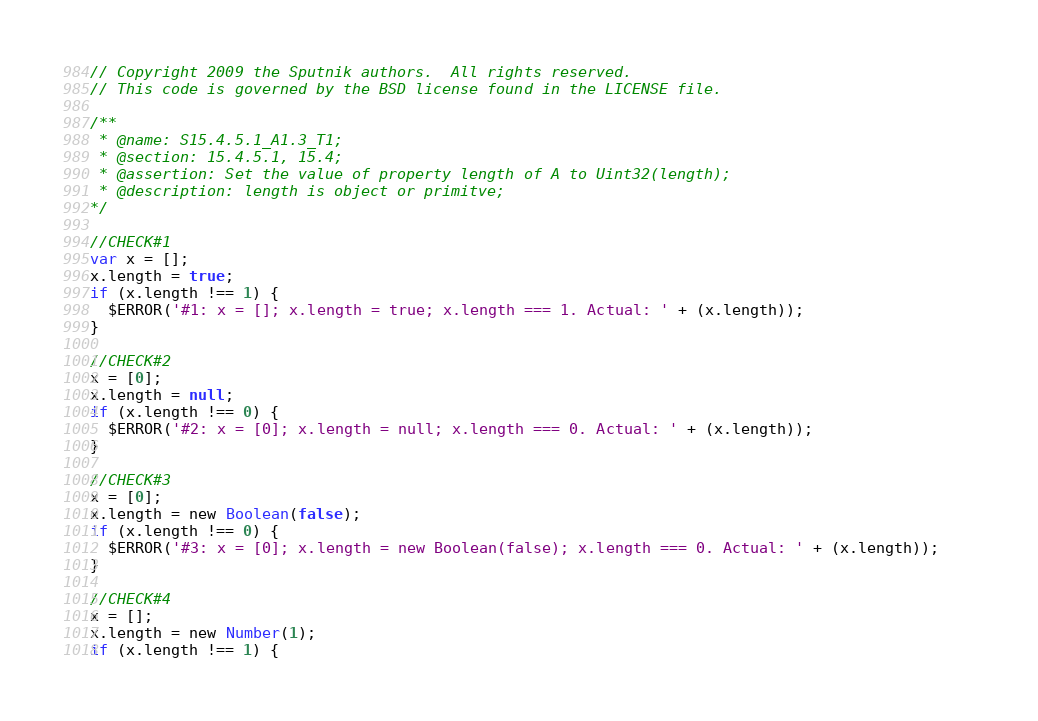<code> <loc_0><loc_0><loc_500><loc_500><_JavaScript_>// Copyright 2009 the Sputnik authors.  All rights reserved.
// This code is governed by the BSD license found in the LICENSE file.

/**
 * @name: S15.4.5.1_A1.3_T1;
 * @section: 15.4.5.1, 15.4;
 * @assertion: Set the value of property length of A to Uint32(length);
 * @description: length is object or primitve; 
*/

//CHECK#1
var x = [];
x.length = true;
if (x.length !== 1) {  
  $ERROR('#1: x = []; x.length = true; x.length === 1. Actual: ' + (x.length));    
}

//CHECK#2
x = [0];
x.length = null;
if (x.length !== 0) {  
  $ERROR('#2: x = [0]; x.length = null; x.length === 0. Actual: ' + (x.length));    
}

//CHECK#3
x = [0];
x.length = new Boolean(false);
if (x.length !== 0) {  
  $ERROR('#3: x = [0]; x.length = new Boolean(false); x.length === 0. Actual: ' + (x.length));    
}

//CHECK#4
x = [];
x.length = new Number(1);
if (x.length !== 1) {  </code> 